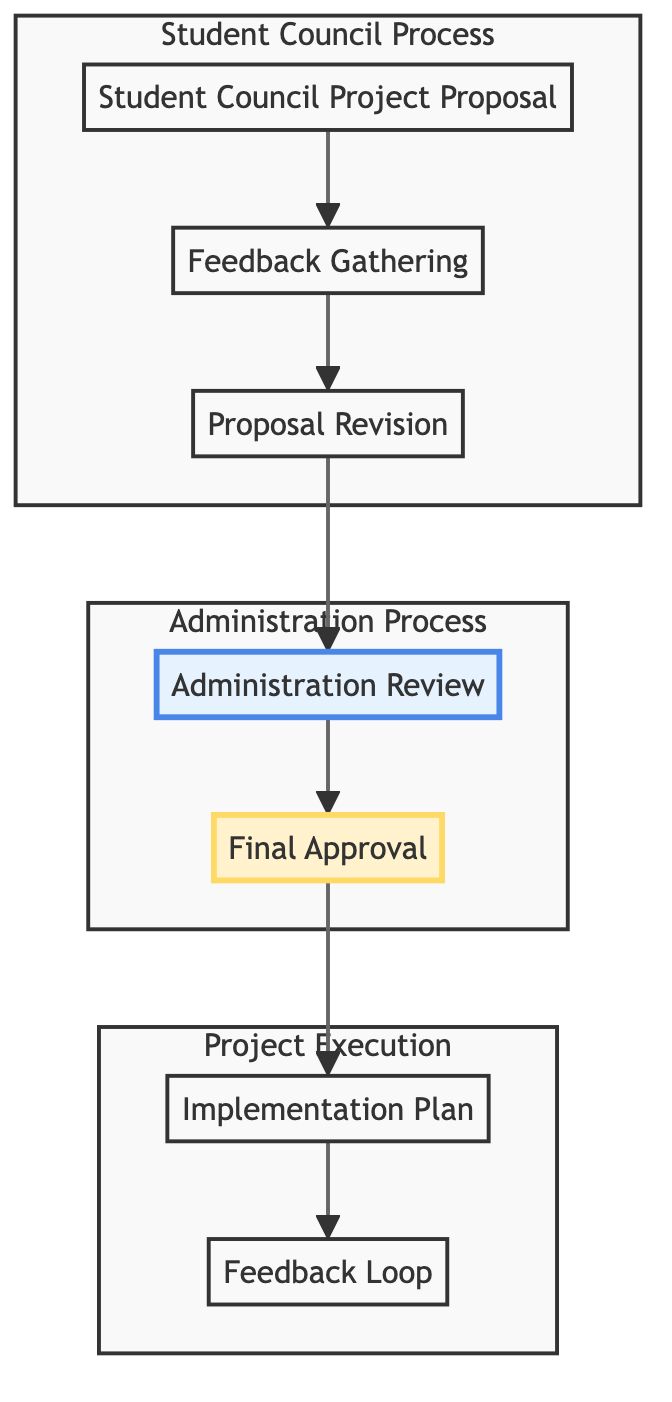What is the first step in the flow chart? The first step is the "Student Council Project Proposal," which is where the project details are initially drafted.
Answer: Student Council Project Proposal How many nodes are in the diagram? By counting each distinct step in the flow chart, there are a total of 7 nodes.
Answer: 7 Which node follows the "Proposal Revision"? After the "Proposal Revision," the next step is the "Administration Review," which involves evaluating the revised proposal.
Answer: Administration Review What is the last step in the process outlined in the diagram? The final step in the process is the "Feedback Loop," where ongoing feedback is collected during project implementation.
Answer: Feedback Loop Which subgraph contains the "Final Approval"? The "Final Approval" is contained within the "Administration Process" subgraph, indicating that it is part of the administrative review stage.
Answer: Administration Process What happens if the proposal gets approved? If the proposal receives approval, it moves into the "Implementation Plan" stage, where the detailed execution plan is developed.
Answer: Implementation Plan How many subgraphs are present in the diagram? There are three subgraphs in the diagram, representing distinct phases: "Student Council Process," "Administration Process," and "Project Execution."
Answer: 3 What is the main purpose of the "Feedback Gathering" step? The main purpose of "Feedback Gathering" is to collect opinions and suggestions from students, teachers, and the community regarding the proposal.
Answer: Collecting feedback Which node emphasizes the administration's role? The "Administration Review" node is emphasized to highlight its importance in evaluating the revised proposal for feasibility and alignment.
Answer: Administration Review 